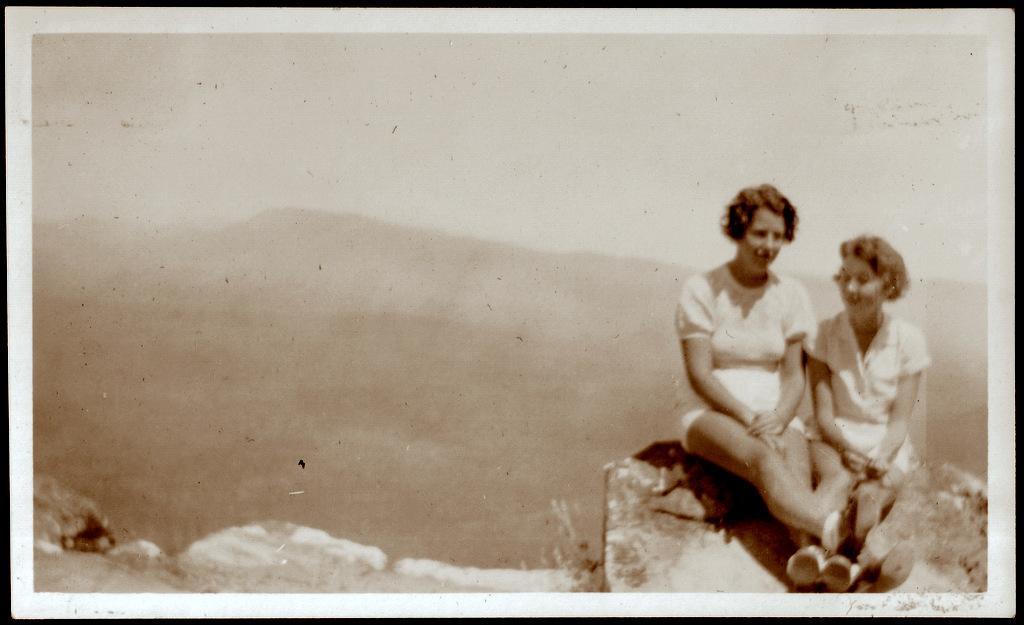Can you describe this image briefly? It is an edited image, there are two people sitting on a rock. 